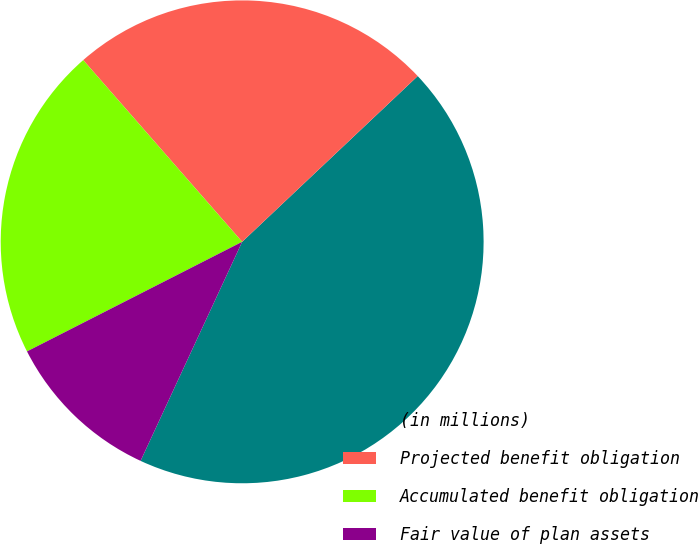Convert chart. <chart><loc_0><loc_0><loc_500><loc_500><pie_chart><fcel>(in millions)<fcel>Projected benefit obligation<fcel>Accumulated benefit obligation<fcel>Fair value of plan assets<nl><fcel>43.95%<fcel>24.39%<fcel>21.06%<fcel>10.59%<nl></chart> 